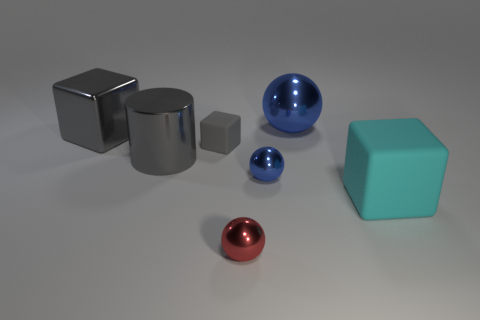Subtract all big cubes. How many cubes are left? 1 Subtract all brown spheres. How many gray blocks are left? 2 Add 1 red matte cylinders. How many objects exist? 8 Subtract 1 cubes. How many cubes are left? 2 Subtract all blocks. How many objects are left? 4 Subtract all gray blocks. How many blocks are left? 1 Subtract all yellow cylinders. Subtract all red balls. How many cylinders are left? 1 Subtract all large green rubber things. Subtract all shiny cubes. How many objects are left? 6 Add 6 tiny rubber blocks. How many tiny rubber blocks are left? 7 Add 2 large gray cubes. How many large gray cubes exist? 3 